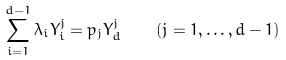<formula> <loc_0><loc_0><loc_500><loc_500>\sum _ { i = 1 } ^ { d - 1 } \lambda _ { i } Y _ { i } ^ { j } = p _ { j } Y _ { d } ^ { j } \quad ( j = 1 , \dots , d - 1 )</formula> 